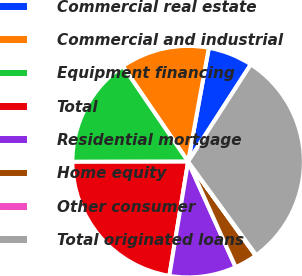Convert chart to OTSL. <chart><loc_0><loc_0><loc_500><loc_500><pie_chart><fcel>Commercial real estate<fcel>Commercial and industrial<fcel>Equipment financing<fcel>Total<fcel>Residential mortgage<fcel>Home equity<fcel>Other consumer<fcel>Total originated loans<nl><fcel>6.25%<fcel>12.41%<fcel>15.48%<fcel>22.38%<fcel>9.33%<fcel>3.18%<fcel>0.1%<fcel>30.87%<nl></chart> 